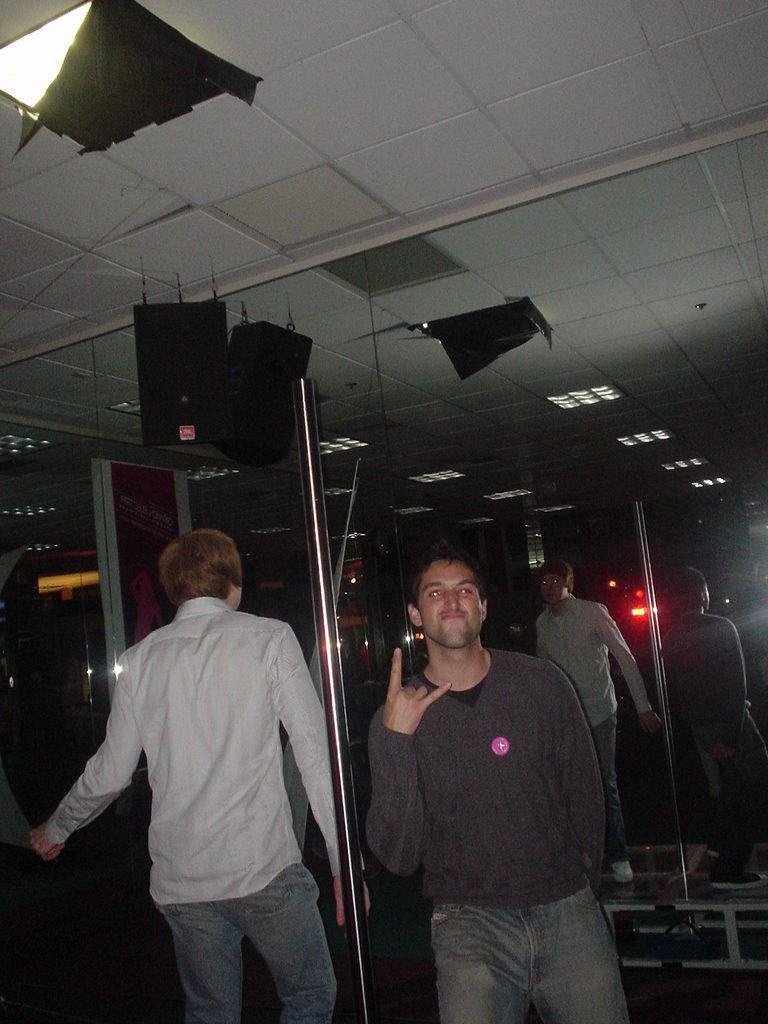How many people are in the image? There are two persons standing in the image. What objects are present in the image that reflect light or images? There are mirrors in the image. What can be seen attached to the ceiling in the image? There are objects fixed to the ceiling in the image. What is the color of the background in the image? The background of the image is dark. What type of cabbage can be seen growing in the image? There is no cabbage present in the image. What kind of rhythm is being played by the carriage in the image? There is no carriage or rhythm present in the image. 